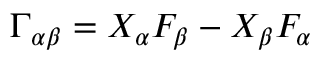<formula> <loc_0><loc_0><loc_500><loc_500>\Gamma _ { \alpha \beta } = X _ { \alpha } F _ { \beta } - X _ { \beta } F _ { \alpha }</formula> 